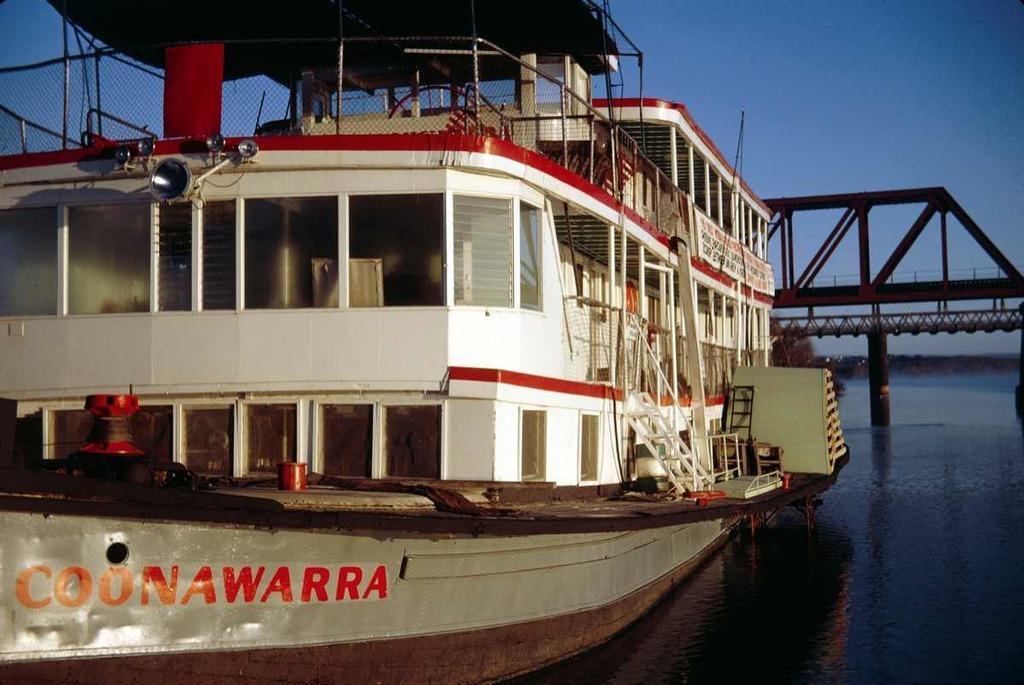In one or two sentences, can you explain what this image depicts? In this image there is a boat on the river, behind the boat there is a bridge. 